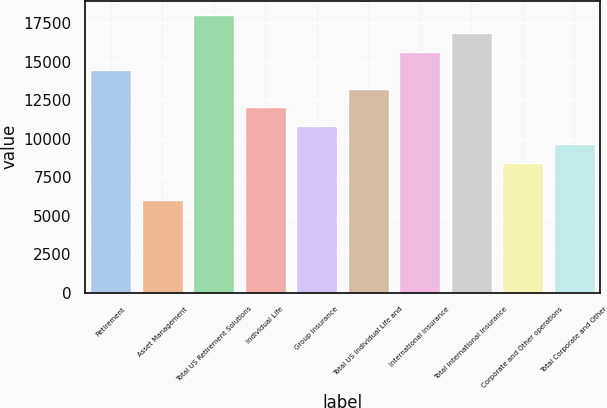Convert chart to OTSL. <chart><loc_0><loc_0><loc_500><loc_500><bar_chart><fcel>Retirement<fcel>Asset Management<fcel>Total US Retirement Solutions<fcel>Individual Life<fcel>Group Insurance<fcel>Total US Individual Life and<fcel>International Insurance<fcel>Total International Insurance<fcel>Corporate and Other operations<fcel>Total Corporate and Other<nl><fcel>14454.6<fcel>6024.54<fcel>18067.5<fcel>12046<fcel>10841.7<fcel>13250.3<fcel>15658.9<fcel>16863.2<fcel>8433.14<fcel>9637.44<nl></chart> 